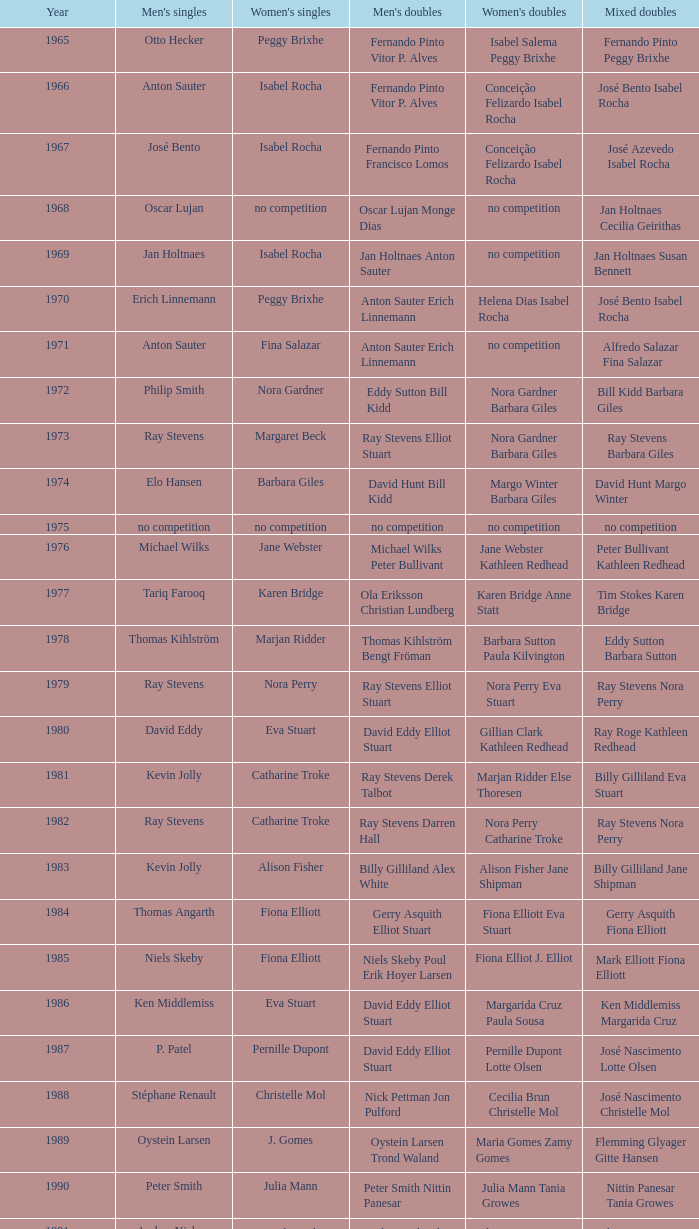What is the average year with alfredo salazar fina salazar in mixed doubles? 1971.0. 